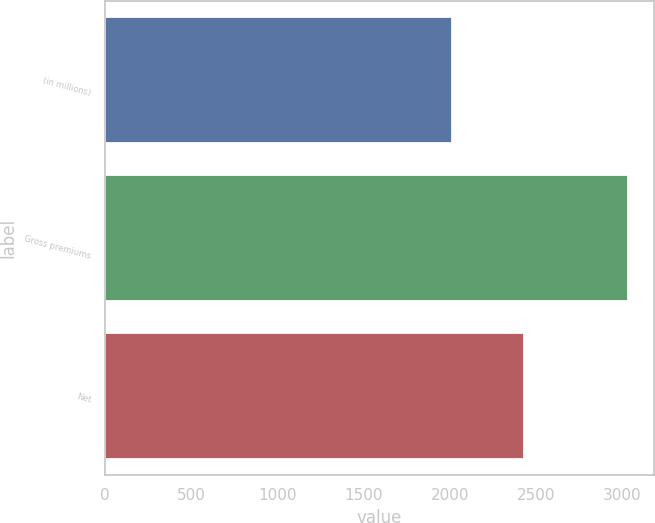Convert chart to OTSL. <chart><loc_0><loc_0><loc_500><loc_500><bar_chart><fcel>(in millions)<fcel>Gross premiums<fcel>Net<nl><fcel>2012<fcel>3030<fcel>2428<nl></chart> 